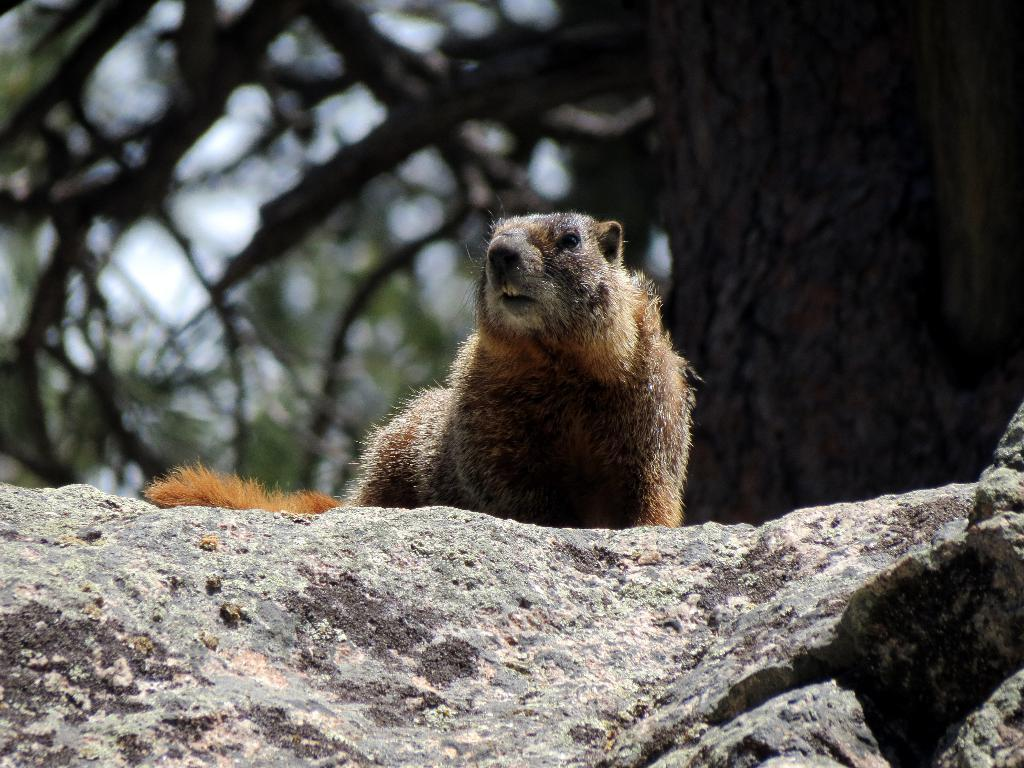What type of animal can be seen in the image? There is an animal visible on a stone in the image. What natural element is present at the top of the image? There is a tree visible at the top of the image. What type of iron can be seen in the image? There is no iron present in the image. What type of juice is being consumed by the animal in the image? There is no juice or indication of the animal consuming anything in the image. 